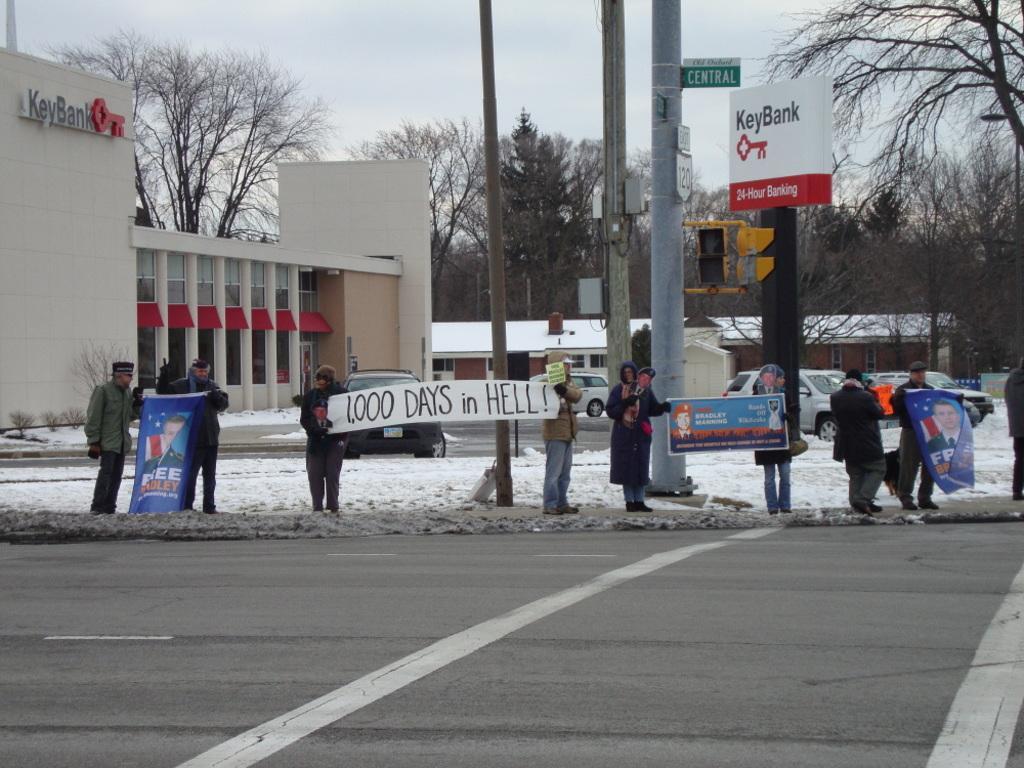Could you give a brief overview of what you see in this image? In this image, there are a few people, vehicles, buildings, poles and trees. We can see the ground and some boards with text. We can see the sky and some snow. 